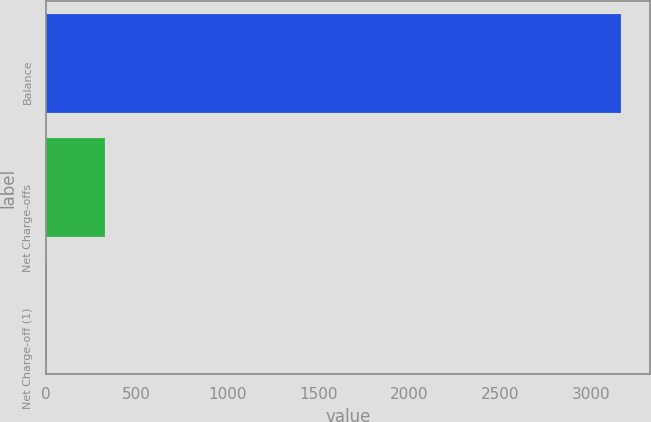Convert chart. <chart><loc_0><loc_0><loc_500><loc_500><bar_chart><fcel>Balance<fcel>Net Charge-offs<fcel>Net Charge-off (1)<nl><fcel>3167<fcel>323.11<fcel>7.12<nl></chart> 